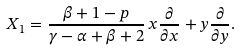Convert formula to latex. <formula><loc_0><loc_0><loc_500><loc_500>X _ { 1 } = \frac { \beta + 1 - p } { \gamma - \alpha + \beta + 2 } \, x \frac { \partial } { \partial x } + y \frac { \partial } { \partial y } .</formula> 